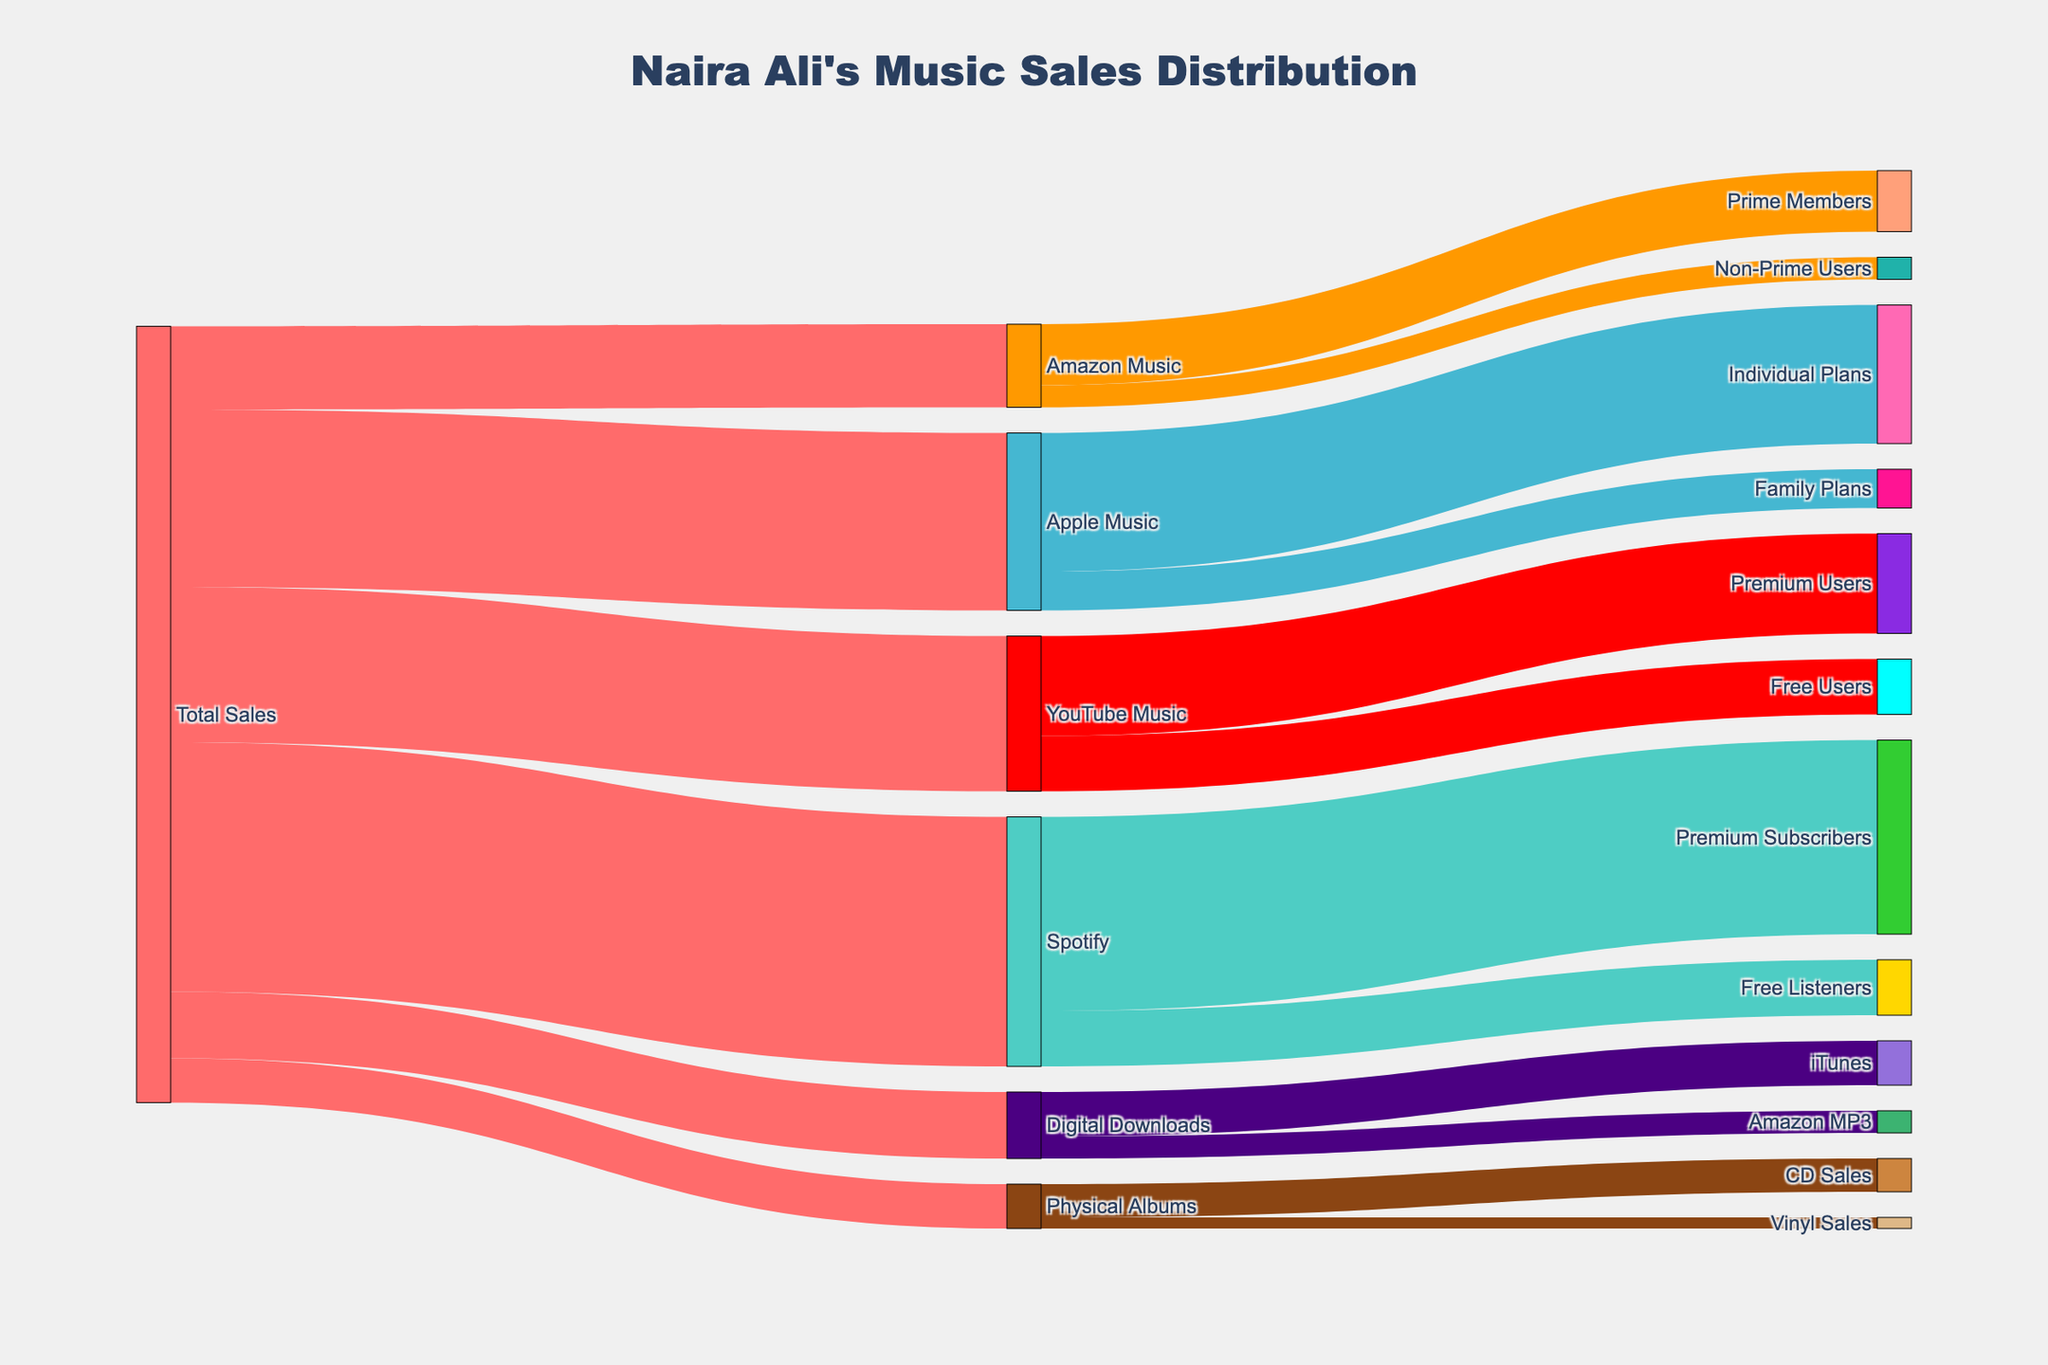How many total sales are there in the diagram? The diagram shows the total sales as the originating node labeled "Total Sales".
Answer: 1,400,000 What's the title of the Sankey diagram? The title of the diagram is displayed at the top of the figure.
Answer: Naira Ali's Music Sales Distribution How many categories of streaming platforms are shown? The diagram shows labeled nodes for the streaming platforms under "Total Sales". Count these nodes.
Answer: 4 Which streaming platform has the most sales? Look for the streaming platform connected to "Total Sales" with the highest value link.
Answer: Spotify Which category under Apple Music has more sales, Individual Plans or Family Plans? Check the target nodes connected to Apple Music and compare their values.
Answer: Individual Plans What is the combined sales value for Physical Albums and Digital Downloads? Locate the links for Physical Albums and Digital Downloads from Total Sales and sum their values.
Answer: 200,000 How do Premium Subscribers in Spotify compare to Free Listeners in Spotify? Check the target nodes connected to Spotify for Premium Subscribers and Free Listeners, and compare their values.
Answer: Premium Subscribers are more than Free Listeners What is the total number of sales for all free user categories across the streaming platforms? Locate the links representing free user categories under each platform (YouTube Music, Spotify) and sum their values.
Answer: 200,000 Which category has fewer sales, CD Sales or Vinyl Sales under Physical Albums? Look for the target nodes under Physical Albums and compare their values.
Answer: Vinyl Sales How many sales come from Amazon MP3 downloads? Locate the link labeled Amazon MP3 under Digital Downloads, and check its value.
Answer: 40,000 